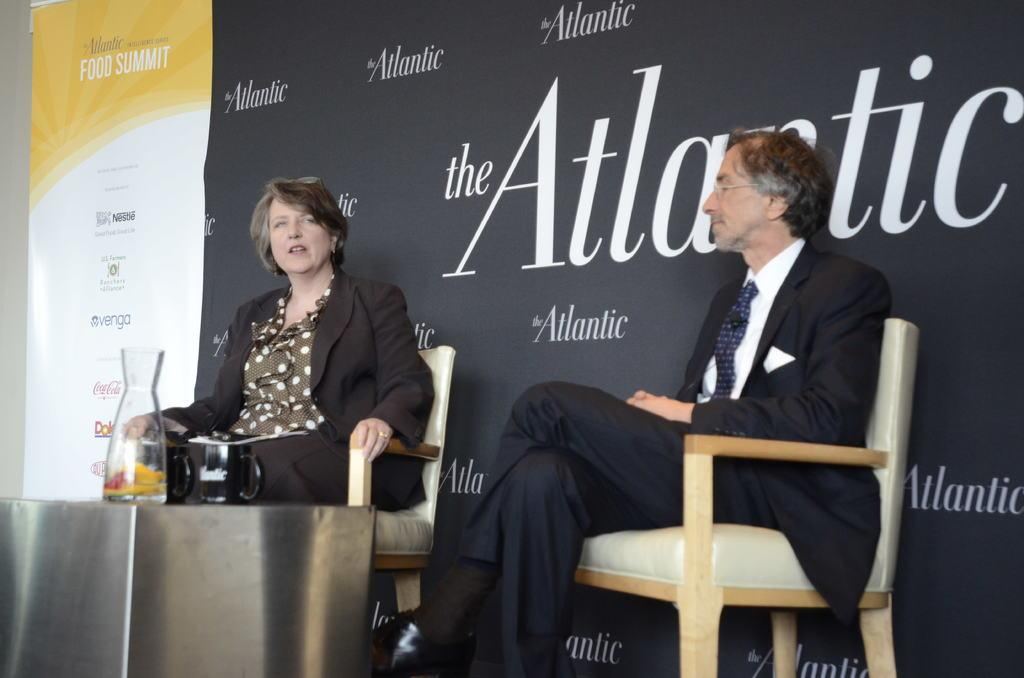How many people are in the image? There are two people in the image. What are the people wearing? The people are wearing black suits. What object is in front of the people? There is a jug in front of the people. What color is the poster in the background? The poster in the background is black. What type of polish is being applied to the table in the image? There is no table or polish present in the image. Can you describe the people jumping in the image? There are no people jumping in the image; the two people are standing still. 